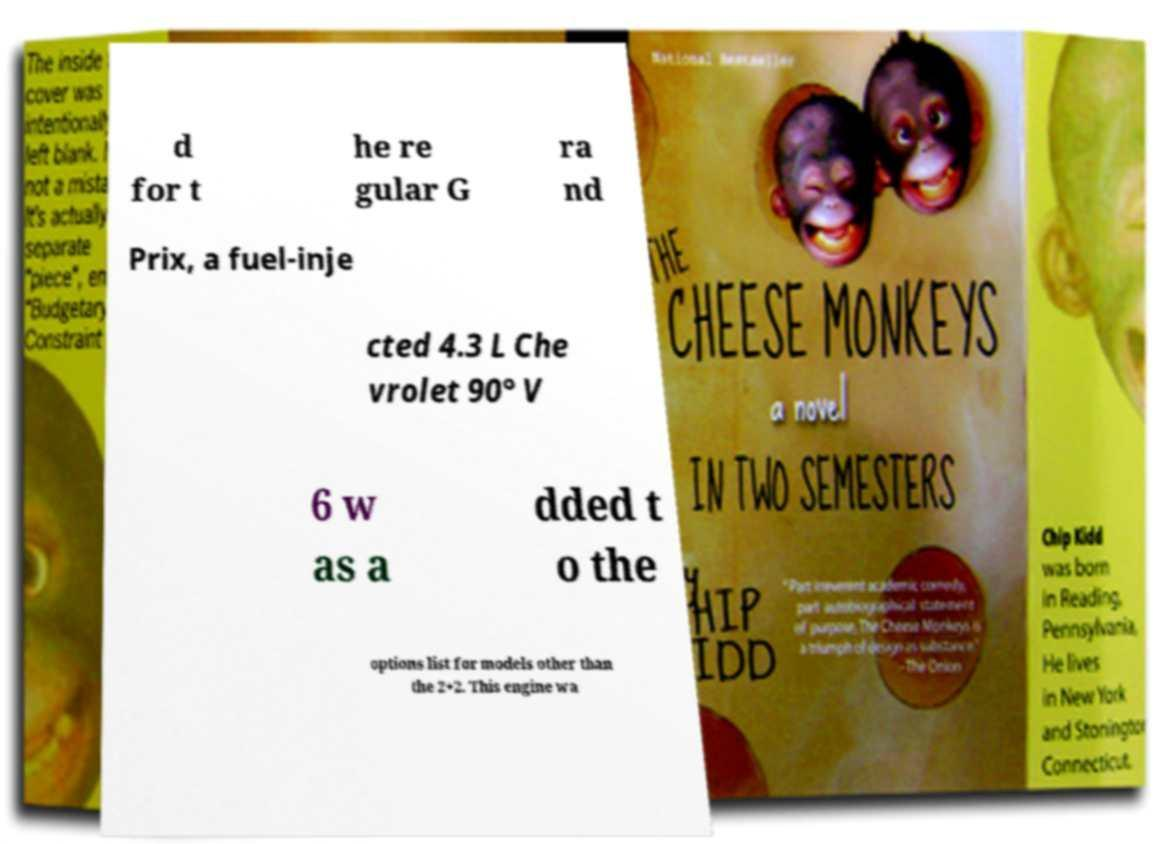I need the written content from this picture converted into text. Can you do that? d for t he re gular G ra nd Prix, a fuel-inje cted 4.3 L Che vrolet 90° V 6 w as a dded t o the options list for models other than the 2+2. This engine wa 